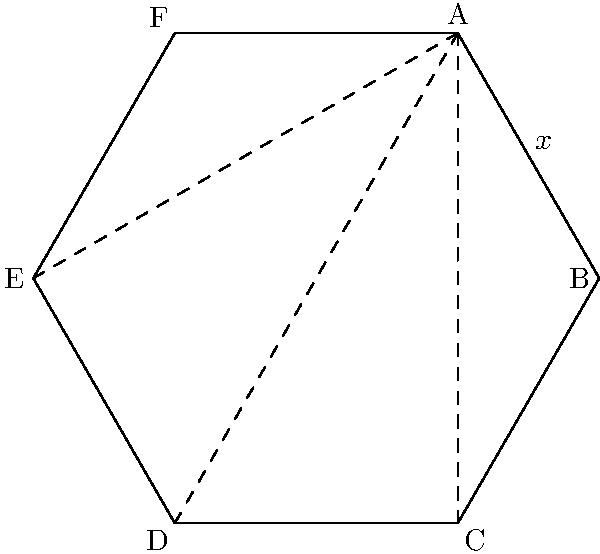En un hexágono regular, ¿cuál es la medida de cada ángulo interior? Exprese su respuesta en grados. Para encontrar la medida de cada ángulo interior de un hexágono regular, seguiremos estos pasos:

1) La suma de los ángulos interiores de cualquier polígono se puede calcular con la fórmula:
   $$(n-2) \times 180°$$
   donde $n$ es el número de lados.

2) Para un hexágono, $n = 6$, así que la suma de los ángulos interiores es:
   $$(6-2) \times 180° = 4 \times 180° = 720°$$

3) En un polígono regular, todos los ángulos interiores son iguales. Por lo tanto, para encontrar la medida de cada ángulo, dividimos la suma total por el número de ángulos:

   $$\frac{720°}{6} = 120°$$

4) Podemos verificar esto observando que un hexágono regular se puede dividir en 6 triángulos equiláteros. Cada triángulo equilátero tiene ángulos de 60°, y dos de estos ángulos forman cada ángulo interior del hexágono:

   $$60° + 60° = 120°$$

Por lo tanto, cada ángulo interior de un hexágono regular mide 120°.
Answer: 120° 